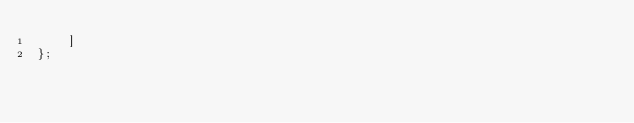Convert code to text. <code><loc_0><loc_0><loc_500><loc_500><_JavaScript_>    ]
};
</code> 